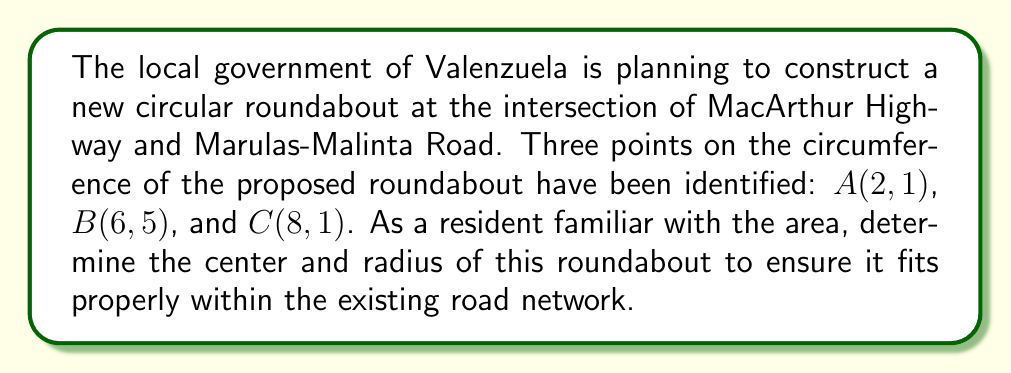Can you answer this question? To find the center and radius of the circular roundabout, we'll follow these steps:

1) The center of the circle is equidistant from all points on the circumference. We can find it by calculating the perpendicular bisectors of any two chords and finding their intersection point.

2) Let's choose chords AB and BC. We'll find their midpoints first:

   Midpoint of AB: $M_1 = (\frac{2+6}{2}, \frac{1+5}{2}) = (4, 3)$
   Midpoint of BC: $M_2 = (\frac{6+8}{2}, \frac{5+1}{2}) = (7, 3)$

3) The slopes of AB and BC are:

   Slope of AB: $m_{AB} = \frac{5-1}{6-2} = 1$
   Slope of BC: $m_{BC} = \frac{1-5}{8-6} = -2$

4) The perpendicular bisectors will have slopes that are negative reciprocals of these:

   Slope of perpendicular bisector of AB: $m_1 = -1$
   Slope of perpendicular bisector of BC: $m_2 = \frac{1}{2}$

5) We can now write equations for these perpendicular bisectors:

   Line 1: $y - 3 = -1(x - 4)$ or $y = -x + 7$
   Line 2: $y - 3 = \frac{1}{2}(x - 7)$ or $y = \frac{1}{2}x - \frac{1}{2}$

6) To find the center, we solve these equations simultaneously:

   $-x + 7 = \frac{1}{2}x - \frac{1}{2}$
   $-\frac{3}{2}x = -\frac{15}{2}$
   $x = 5$

   Substituting back:
   $y = -5 + 7 = 2$

   So, the center is at (5, 2).

7) To find the radius, we can calculate the distance from the center to any of the given points. Let's use point A(2, 1):

   $r = \sqrt{(5-2)^2 + (2-1)^2} = \sqrt{9 + 1} = \sqrt{10} \approx 3.16$

Therefore, the center of the roundabout is at (5, 2) and its radius is $\sqrt{10}$ units.
Answer: Center: (5, 2); Radius: $\sqrt{10}$ 